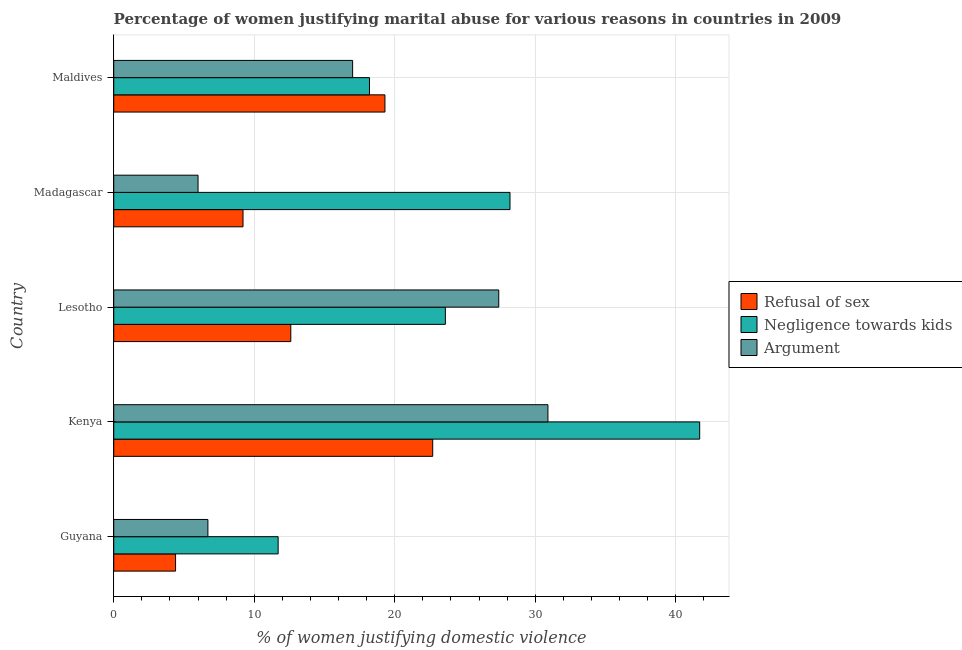How many groups of bars are there?
Your answer should be very brief. 5. Are the number of bars per tick equal to the number of legend labels?
Your answer should be compact. Yes. Are the number of bars on each tick of the Y-axis equal?
Provide a succinct answer. Yes. How many bars are there on the 4th tick from the bottom?
Make the answer very short. 3. What is the label of the 4th group of bars from the top?
Give a very brief answer. Kenya. What is the percentage of women justifying domestic violence due to refusal of sex in Guyana?
Provide a succinct answer. 4.4. Across all countries, what is the maximum percentage of women justifying domestic violence due to negligence towards kids?
Your response must be concise. 41.7. In which country was the percentage of women justifying domestic violence due to refusal of sex maximum?
Provide a short and direct response. Kenya. In which country was the percentage of women justifying domestic violence due to arguments minimum?
Your answer should be compact. Madagascar. What is the total percentage of women justifying domestic violence due to negligence towards kids in the graph?
Provide a succinct answer. 123.4. What is the average percentage of women justifying domestic violence due to refusal of sex per country?
Provide a succinct answer. 13.64. What is the ratio of the percentage of women justifying domestic violence due to arguments in Kenya to that in Maldives?
Provide a short and direct response. 1.82. What is the difference between the highest and the lowest percentage of women justifying domestic violence due to refusal of sex?
Your response must be concise. 18.3. What does the 2nd bar from the top in Guyana represents?
Your answer should be very brief. Negligence towards kids. What does the 3rd bar from the bottom in Guyana represents?
Your answer should be very brief. Argument. Is it the case that in every country, the sum of the percentage of women justifying domestic violence due to refusal of sex and percentage of women justifying domestic violence due to negligence towards kids is greater than the percentage of women justifying domestic violence due to arguments?
Your response must be concise. Yes. Are all the bars in the graph horizontal?
Provide a succinct answer. Yes. What is the difference between two consecutive major ticks on the X-axis?
Provide a succinct answer. 10. What is the title of the graph?
Ensure brevity in your answer.  Percentage of women justifying marital abuse for various reasons in countries in 2009. Does "Female employers" appear as one of the legend labels in the graph?
Provide a short and direct response. No. What is the label or title of the X-axis?
Keep it short and to the point. % of women justifying domestic violence. What is the label or title of the Y-axis?
Provide a succinct answer. Country. What is the % of women justifying domestic violence of Argument in Guyana?
Give a very brief answer. 6.7. What is the % of women justifying domestic violence in Refusal of sex in Kenya?
Provide a short and direct response. 22.7. What is the % of women justifying domestic violence in Negligence towards kids in Kenya?
Provide a short and direct response. 41.7. What is the % of women justifying domestic violence of Argument in Kenya?
Make the answer very short. 30.9. What is the % of women justifying domestic violence in Negligence towards kids in Lesotho?
Keep it short and to the point. 23.6. What is the % of women justifying domestic violence in Argument in Lesotho?
Keep it short and to the point. 27.4. What is the % of women justifying domestic violence of Refusal of sex in Madagascar?
Your answer should be very brief. 9.2. What is the % of women justifying domestic violence in Negligence towards kids in Madagascar?
Keep it short and to the point. 28.2. What is the % of women justifying domestic violence of Refusal of sex in Maldives?
Your answer should be compact. 19.3. What is the % of women justifying domestic violence of Negligence towards kids in Maldives?
Keep it short and to the point. 18.2. What is the % of women justifying domestic violence in Argument in Maldives?
Provide a short and direct response. 17. Across all countries, what is the maximum % of women justifying domestic violence in Refusal of sex?
Your response must be concise. 22.7. Across all countries, what is the maximum % of women justifying domestic violence of Negligence towards kids?
Give a very brief answer. 41.7. Across all countries, what is the maximum % of women justifying domestic violence in Argument?
Provide a succinct answer. 30.9. Across all countries, what is the minimum % of women justifying domestic violence in Refusal of sex?
Your response must be concise. 4.4. Across all countries, what is the minimum % of women justifying domestic violence of Argument?
Keep it short and to the point. 6. What is the total % of women justifying domestic violence in Refusal of sex in the graph?
Offer a very short reply. 68.2. What is the total % of women justifying domestic violence in Negligence towards kids in the graph?
Your answer should be compact. 123.4. What is the difference between the % of women justifying domestic violence in Refusal of sex in Guyana and that in Kenya?
Your response must be concise. -18.3. What is the difference between the % of women justifying domestic violence in Argument in Guyana and that in Kenya?
Offer a terse response. -24.2. What is the difference between the % of women justifying domestic violence in Negligence towards kids in Guyana and that in Lesotho?
Ensure brevity in your answer.  -11.9. What is the difference between the % of women justifying domestic violence of Argument in Guyana and that in Lesotho?
Your answer should be compact. -20.7. What is the difference between the % of women justifying domestic violence of Refusal of sex in Guyana and that in Madagascar?
Keep it short and to the point. -4.8. What is the difference between the % of women justifying domestic violence of Negligence towards kids in Guyana and that in Madagascar?
Make the answer very short. -16.5. What is the difference between the % of women justifying domestic violence of Argument in Guyana and that in Madagascar?
Offer a terse response. 0.7. What is the difference between the % of women justifying domestic violence of Refusal of sex in Guyana and that in Maldives?
Make the answer very short. -14.9. What is the difference between the % of women justifying domestic violence in Negligence towards kids in Guyana and that in Maldives?
Offer a terse response. -6.5. What is the difference between the % of women justifying domestic violence in Refusal of sex in Kenya and that in Lesotho?
Your answer should be very brief. 10.1. What is the difference between the % of women justifying domestic violence of Negligence towards kids in Kenya and that in Lesotho?
Your answer should be very brief. 18.1. What is the difference between the % of women justifying domestic violence in Refusal of sex in Kenya and that in Madagascar?
Offer a very short reply. 13.5. What is the difference between the % of women justifying domestic violence in Negligence towards kids in Kenya and that in Madagascar?
Offer a terse response. 13.5. What is the difference between the % of women justifying domestic violence of Argument in Kenya and that in Madagascar?
Make the answer very short. 24.9. What is the difference between the % of women justifying domestic violence in Refusal of sex in Kenya and that in Maldives?
Ensure brevity in your answer.  3.4. What is the difference between the % of women justifying domestic violence of Argument in Kenya and that in Maldives?
Offer a very short reply. 13.9. What is the difference between the % of women justifying domestic violence of Refusal of sex in Lesotho and that in Madagascar?
Provide a succinct answer. 3.4. What is the difference between the % of women justifying domestic violence in Argument in Lesotho and that in Madagascar?
Offer a terse response. 21.4. What is the difference between the % of women justifying domestic violence in Negligence towards kids in Lesotho and that in Maldives?
Your response must be concise. 5.4. What is the difference between the % of women justifying domestic violence in Argument in Lesotho and that in Maldives?
Provide a succinct answer. 10.4. What is the difference between the % of women justifying domestic violence in Refusal of sex in Madagascar and that in Maldives?
Ensure brevity in your answer.  -10.1. What is the difference between the % of women justifying domestic violence in Negligence towards kids in Madagascar and that in Maldives?
Give a very brief answer. 10. What is the difference between the % of women justifying domestic violence of Argument in Madagascar and that in Maldives?
Your answer should be very brief. -11. What is the difference between the % of women justifying domestic violence of Refusal of sex in Guyana and the % of women justifying domestic violence of Negligence towards kids in Kenya?
Offer a very short reply. -37.3. What is the difference between the % of women justifying domestic violence in Refusal of sex in Guyana and the % of women justifying domestic violence in Argument in Kenya?
Provide a short and direct response. -26.5. What is the difference between the % of women justifying domestic violence in Negligence towards kids in Guyana and the % of women justifying domestic violence in Argument in Kenya?
Provide a short and direct response. -19.2. What is the difference between the % of women justifying domestic violence in Refusal of sex in Guyana and the % of women justifying domestic violence in Negligence towards kids in Lesotho?
Make the answer very short. -19.2. What is the difference between the % of women justifying domestic violence of Negligence towards kids in Guyana and the % of women justifying domestic violence of Argument in Lesotho?
Ensure brevity in your answer.  -15.7. What is the difference between the % of women justifying domestic violence in Refusal of sex in Guyana and the % of women justifying domestic violence in Negligence towards kids in Madagascar?
Keep it short and to the point. -23.8. What is the difference between the % of women justifying domestic violence in Negligence towards kids in Guyana and the % of women justifying domestic violence in Argument in Madagascar?
Provide a short and direct response. 5.7. What is the difference between the % of women justifying domestic violence of Negligence towards kids in Guyana and the % of women justifying domestic violence of Argument in Maldives?
Your answer should be very brief. -5.3. What is the difference between the % of women justifying domestic violence of Refusal of sex in Kenya and the % of women justifying domestic violence of Argument in Lesotho?
Give a very brief answer. -4.7. What is the difference between the % of women justifying domestic violence of Negligence towards kids in Kenya and the % of women justifying domestic violence of Argument in Lesotho?
Your answer should be very brief. 14.3. What is the difference between the % of women justifying domestic violence in Refusal of sex in Kenya and the % of women justifying domestic violence in Negligence towards kids in Madagascar?
Make the answer very short. -5.5. What is the difference between the % of women justifying domestic violence in Refusal of sex in Kenya and the % of women justifying domestic violence in Argument in Madagascar?
Provide a succinct answer. 16.7. What is the difference between the % of women justifying domestic violence of Negligence towards kids in Kenya and the % of women justifying domestic violence of Argument in Madagascar?
Make the answer very short. 35.7. What is the difference between the % of women justifying domestic violence of Refusal of sex in Kenya and the % of women justifying domestic violence of Argument in Maldives?
Ensure brevity in your answer.  5.7. What is the difference between the % of women justifying domestic violence of Negligence towards kids in Kenya and the % of women justifying domestic violence of Argument in Maldives?
Make the answer very short. 24.7. What is the difference between the % of women justifying domestic violence in Refusal of sex in Lesotho and the % of women justifying domestic violence in Negligence towards kids in Madagascar?
Ensure brevity in your answer.  -15.6. What is the difference between the % of women justifying domestic violence of Negligence towards kids in Lesotho and the % of women justifying domestic violence of Argument in Madagascar?
Your response must be concise. 17.6. What is the difference between the % of women justifying domestic violence in Refusal of sex in Lesotho and the % of women justifying domestic violence in Negligence towards kids in Maldives?
Your answer should be compact. -5.6. What is the difference between the % of women justifying domestic violence of Refusal of sex in Lesotho and the % of women justifying domestic violence of Argument in Maldives?
Ensure brevity in your answer.  -4.4. What is the difference between the % of women justifying domestic violence of Refusal of sex in Madagascar and the % of women justifying domestic violence of Negligence towards kids in Maldives?
Offer a terse response. -9. What is the difference between the % of women justifying domestic violence of Refusal of sex in Madagascar and the % of women justifying domestic violence of Argument in Maldives?
Provide a succinct answer. -7.8. What is the difference between the % of women justifying domestic violence of Negligence towards kids in Madagascar and the % of women justifying domestic violence of Argument in Maldives?
Your answer should be very brief. 11.2. What is the average % of women justifying domestic violence of Refusal of sex per country?
Give a very brief answer. 13.64. What is the average % of women justifying domestic violence of Negligence towards kids per country?
Provide a succinct answer. 24.68. What is the average % of women justifying domestic violence in Argument per country?
Your response must be concise. 17.6. What is the difference between the % of women justifying domestic violence in Refusal of sex and % of women justifying domestic violence in Argument in Guyana?
Your answer should be very brief. -2.3. What is the difference between the % of women justifying domestic violence in Negligence towards kids and % of women justifying domestic violence in Argument in Guyana?
Keep it short and to the point. 5. What is the difference between the % of women justifying domestic violence in Refusal of sex and % of women justifying domestic violence in Negligence towards kids in Kenya?
Make the answer very short. -19. What is the difference between the % of women justifying domestic violence of Negligence towards kids and % of women justifying domestic violence of Argument in Kenya?
Offer a terse response. 10.8. What is the difference between the % of women justifying domestic violence in Refusal of sex and % of women justifying domestic violence in Argument in Lesotho?
Make the answer very short. -14.8. What is the difference between the % of women justifying domestic violence of Refusal of sex and % of women justifying domestic violence of Negligence towards kids in Madagascar?
Give a very brief answer. -19. What is the difference between the % of women justifying domestic violence in Refusal of sex and % of women justifying domestic violence in Argument in Madagascar?
Your answer should be very brief. 3.2. What is the difference between the % of women justifying domestic violence of Refusal of sex and % of women justifying domestic violence of Argument in Maldives?
Your answer should be compact. 2.3. What is the difference between the % of women justifying domestic violence in Negligence towards kids and % of women justifying domestic violence in Argument in Maldives?
Your response must be concise. 1.2. What is the ratio of the % of women justifying domestic violence in Refusal of sex in Guyana to that in Kenya?
Your response must be concise. 0.19. What is the ratio of the % of women justifying domestic violence of Negligence towards kids in Guyana to that in Kenya?
Give a very brief answer. 0.28. What is the ratio of the % of women justifying domestic violence of Argument in Guyana to that in Kenya?
Offer a very short reply. 0.22. What is the ratio of the % of women justifying domestic violence in Refusal of sex in Guyana to that in Lesotho?
Your response must be concise. 0.35. What is the ratio of the % of women justifying domestic violence in Negligence towards kids in Guyana to that in Lesotho?
Make the answer very short. 0.5. What is the ratio of the % of women justifying domestic violence of Argument in Guyana to that in Lesotho?
Your answer should be very brief. 0.24. What is the ratio of the % of women justifying domestic violence in Refusal of sex in Guyana to that in Madagascar?
Offer a very short reply. 0.48. What is the ratio of the % of women justifying domestic violence of Negligence towards kids in Guyana to that in Madagascar?
Offer a terse response. 0.41. What is the ratio of the % of women justifying domestic violence of Argument in Guyana to that in Madagascar?
Your response must be concise. 1.12. What is the ratio of the % of women justifying domestic violence of Refusal of sex in Guyana to that in Maldives?
Ensure brevity in your answer.  0.23. What is the ratio of the % of women justifying domestic violence in Negligence towards kids in Guyana to that in Maldives?
Ensure brevity in your answer.  0.64. What is the ratio of the % of women justifying domestic violence in Argument in Guyana to that in Maldives?
Offer a very short reply. 0.39. What is the ratio of the % of women justifying domestic violence of Refusal of sex in Kenya to that in Lesotho?
Provide a short and direct response. 1.8. What is the ratio of the % of women justifying domestic violence of Negligence towards kids in Kenya to that in Lesotho?
Ensure brevity in your answer.  1.77. What is the ratio of the % of women justifying domestic violence of Argument in Kenya to that in Lesotho?
Your response must be concise. 1.13. What is the ratio of the % of women justifying domestic violence of Refusal of sex in Kenya to that in Madagascar?
Make the answer very short. 2.47. What is the ratio of the % of women justifying domestic violence in Negligence towards kids in Kenya to that in Madagascar?
Provide a short and direct response. 1.48. What is the ratio of the % of women justifying domestic violence of Argument in Kenya to that in Madagascar?
Your response must be concise. 5.15. What is the ratio of the % of women justifying domestic violence of Refusal of sex in Kenya to that in Maldives?
Offer a very short reply. 1.18. What is the ratio of the % of women justifying domestic violence of Negligence towards kids in Kenya to that in Maldives?
Offer a terse response. 2.29. What is the ratio of the % of women justifying domestic violence in Argument in Kenya to that in Maldives?
Make the answer very short. 1.82. What is the ratio of the % of women justifying domestic violence in Refusal of sex in Lesotho to that in Madagascar?
Ensure brevity in your answer.  1.37. What is the ratio of the % of women justifying domestic violence of Negligence towards kids in Lesotho to that in Madagascar?
Provide a succinct answer. 0.84. What is the ratio of the % of women justifying domestic violence in Argument in Lesotho to that in Madagascar?
Your answer should be compact. 4.57. What is the ratio of the % of women justifying domestic violence in Refusal of sex in Lesotho to that in Maldives?
Provide a short and direct response. 0.65. What is the ratio of the % of women justifying domestic violence in Negligence towards kids in Lesotho to that in Maldives?
Make the answer very short. 1.3. What is the ratio of the % of women justifying domestic violence of Argument in Lesotho to that in Maldives?
Offer a terse response. 1.61. What is the ratio of the % of women justifying domestic violence of Refusal of sex in Madagascar to that in Maldives?
Your answer should be very brief. 0.48. What is the ratio of the % of women justifying domestic violence in Negligence towards kids in Madagascar to that in Maldives?
Ensure brevity in your answer.  1.55. What is the ratio of the % of women justifying domestic violence in Argument in Madagascar to that in Maldives?
Provide a succinct answer. 0.35. What is the difference between the highest and the second highest % of women justifying domestic violence of Argument?
Your answer should be compact. 3.5. What is the difference between the highest and the lowest % of women justifying domestic violence of Refusal of sex?
Make the answer very short. 18.3. What is the difference between the highest and the lowest % of women justifying domestic violence in Negligence towards kids?
Your answer should be very brief. 30. What is the difference between the highest and the lowest % of women justifying domestic violence in Argument?
Keep it short and to the point. 24.9. 